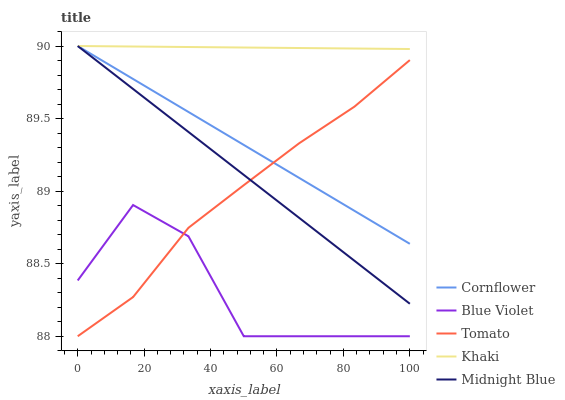Does Blue Violet have the minimum area under the curve?
Answer yes or no. Yes. Does Khaki have the maximum area under the curve?
Answer yes or no. Yes. Does Cornflower have the minimum area under the curve?
Answer yes or no. No. Does Cornflower have the maximum area under the curve?
Answer yes or no. No. Is Khaki the smoothest?
Answer yes or no. Yes. Is Blue Violet the roughest?
Answer yes or no. Yes. Is Cornflower the smoothest?
Answer yes or no. No. Is Cornflower the roughest?
Answer yes or no. No. Does Cornflower have the lowest value?
Answer yes or no. No. Does Midnight Blue have the highest value?
Answer yes or no. Yes. Does Blue Violet have the highest value?
Answer yes or no. No. Is Blue Violet less than Midnight Blue?
Answer yes or no. Yes. Is Midnight Blue greater than Blue Violet?
Answer yes or no. Yes. Does Tomato intersect Blue Violet?
Answer yes or no. Yes. Is Tomato less than Blue Violet?
Answer yes or no. No. Is Tomato greater than Blue Violet?
Answer yes or no. No. Does Blue Violet intersect Midnight Blue?
Answer yes or no. No. 